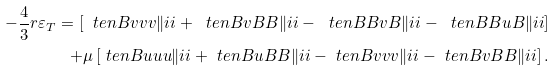<formula> <loc_0><loc_0><loc_500><loc_500>- \frac { 4 } { 3 } r \varepsilon _ { T } = \left [ \ t e n { B } { v v v } { \| i i } + \ t e n { B } { v B B } { \| i i } - \ t e n { B } { B v B } { \| i i } - \ t e n { B } { B u B } { \| i i } \right ] \\ + \mu \left [ \ t e n { B } { u u u } { \| i i } + \ t e n { B } { u B B } { \| i i } - \ t e n { B } { v v v } { \| i i } - \ t e n { B } { v B B } { \| i i } \right ] .</formula> 